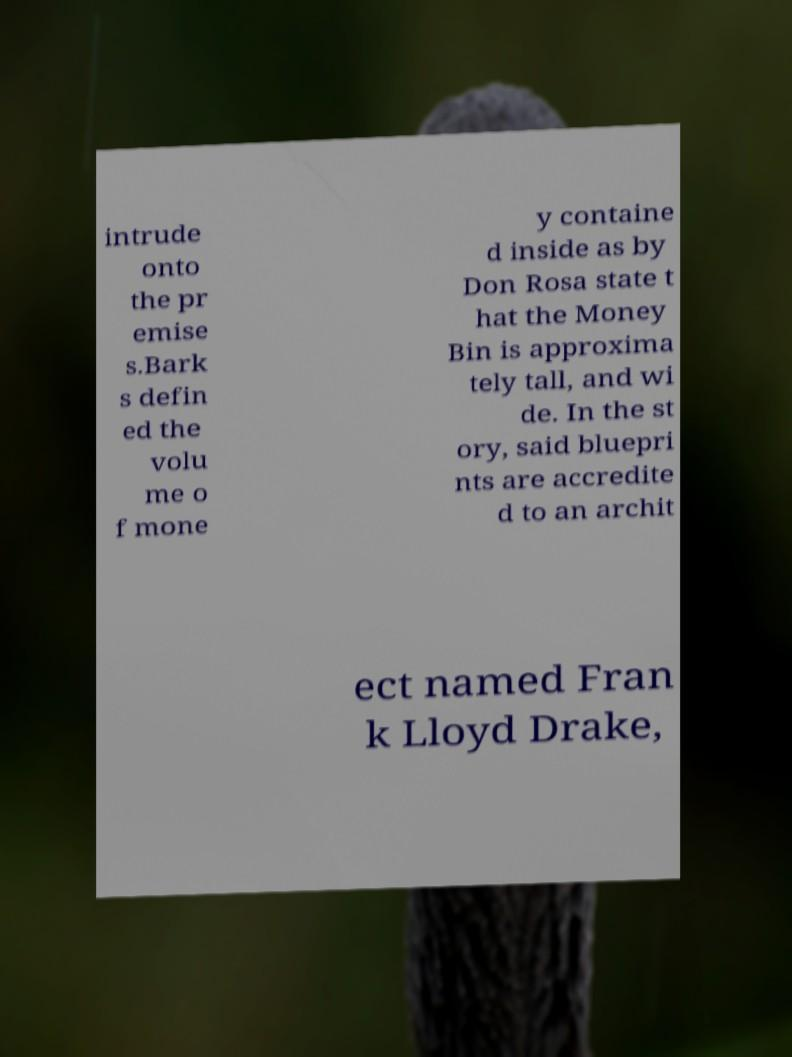Could you assist in decoding the text presented in this image and type it out clearly? intrude onto the pr emise s.Bark s defin ed the volu me o f mone y containe d inside as by Don Rosa state t hat the Money Bin is approxima tely tall, and wi de. In the st ory, said bluepri nts are accredite d to an archit ect named Fran k Lloyd Drake, 